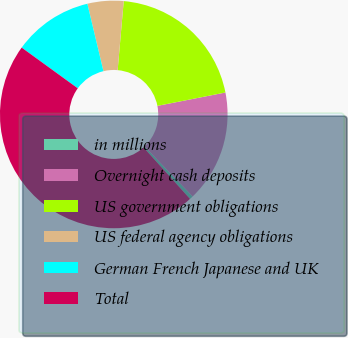Convert chart to OTSL. <chart><loc_0><loc_0><loc_500><loc_500><pie_chart><fcel>in millions<fcel>Overnight cash deposits<fcel>US government obligations<fcel>US federal agency obligations<fcel>German French Japanese and UK<fcel>Total<nl><fcel>0.5%<fcel>15.9%<fcel>20.52%<fcel>5.12%<fcel>11.28%<fcel>46.68%<nl></chart> 